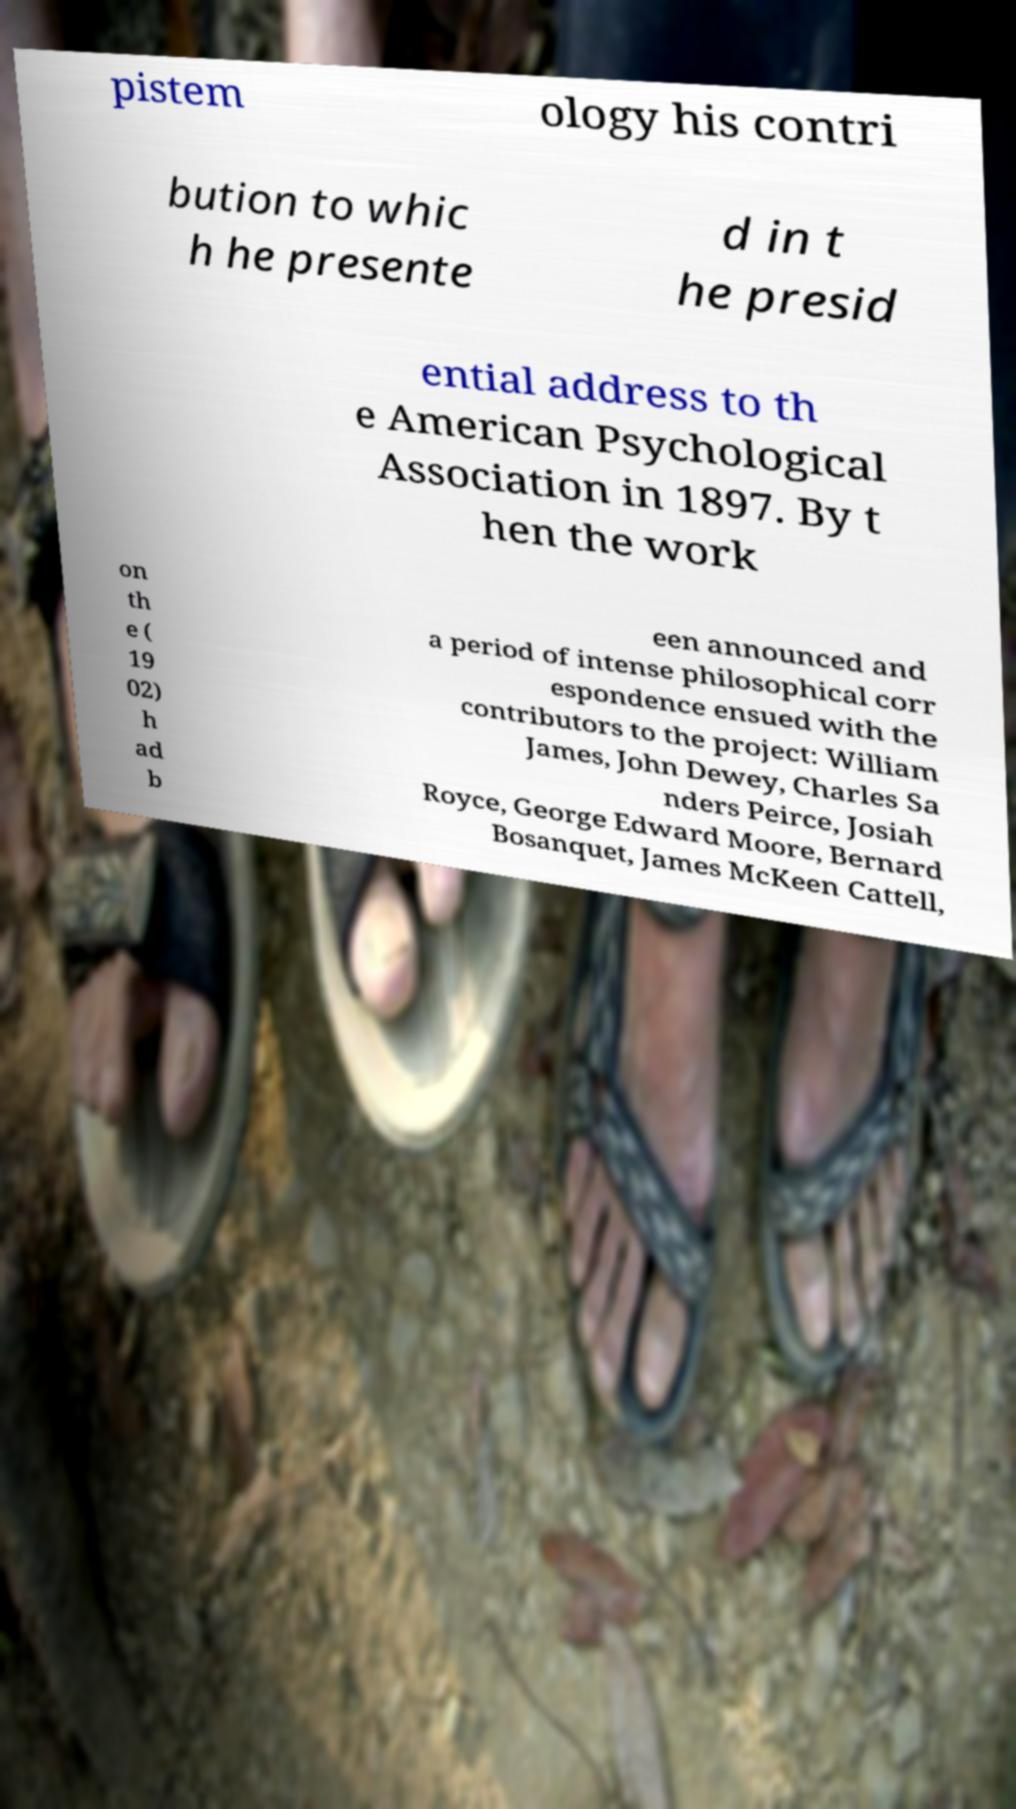Please read and relay the text visible in this image. What does it say? pistem ology his contri bution to whic h he presente d in t he presid ential address to th e American Psychological Association in 1897. By t hen the work on th e ( 19 02) h ad b een announced and a period of intense philosophical corr espondence ensued with the contributors to the project: William James, John Dewey, Charles Sa nders Peirce, Josiah Royce, George Edward Moore, Bernard Bosanquet, James McKeen Cattell, 